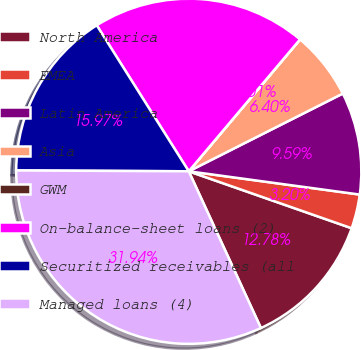Convert chart to OTSL. <chart><loc_0><loc_0><loc_500><loc_500><pie_chart><fcel>North America<fcel>EMEA<fcel>Latin America<fcel>Asia<fcel>GWM<fcel>On-balance-sheet loans (2)<fcel>Securitized receivables (all<fcel>Managed loans (4)<nl><fcel>12.78%<fcel>3.2%<fcel>9.59%<fcel>6.4%<fcel>0.01%<fcel>20.1%<fcel>15.97%<fcel>31.94%<nl></chart> 